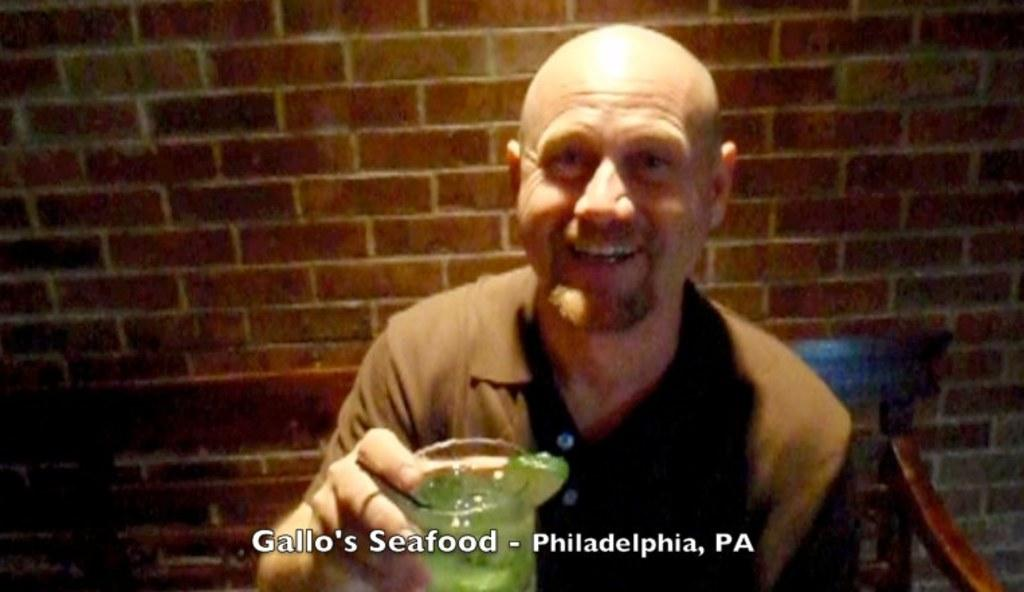What can be seen in the image? There is a person in the image. What is the person doing in the image? The person is holding an object. What can be seen in the background of the image? There is a wall in the background of the image. What type of cushion can be seen on the sand in the image? There is no cushion or sand present in the image. 